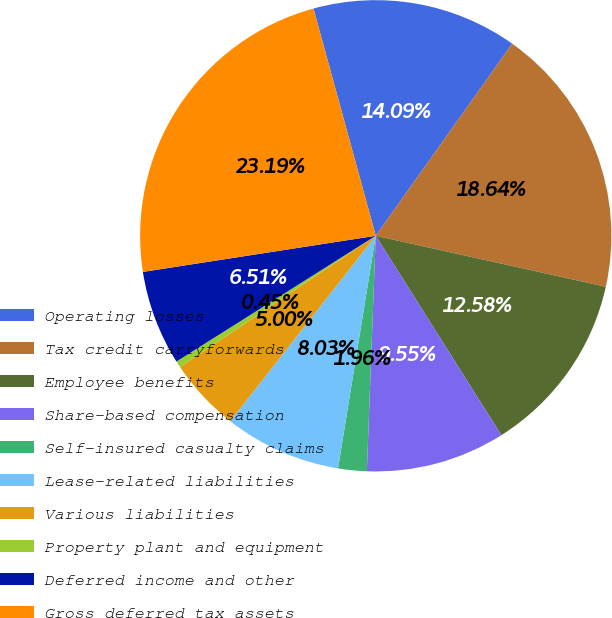Convert chart to OTSL. <chart><loc_0><loc_0><loc_500><loc_500><pie_chart><fcel>Operating losses<fcel>Tax credit carryforwards<fcel>Employee benefits<fcel>Share-based compensation<fcel>Self-insured casualty claims<fcel>Lease-related liabilities<fcel>Various liabilities<fcel>Property plant and equipment<fcel>Deferred income and other<fcel>Gross deferred tax assets<nl><fcel>14.09%<fcel>18.64%<fcel>12.58%<fcel>9.55%<fcel>1.96%<fcel>8.03%<fcel>5.0%<fcel>0.45%<fcel>6.51%<fcel>23.19%<nl></chart> 